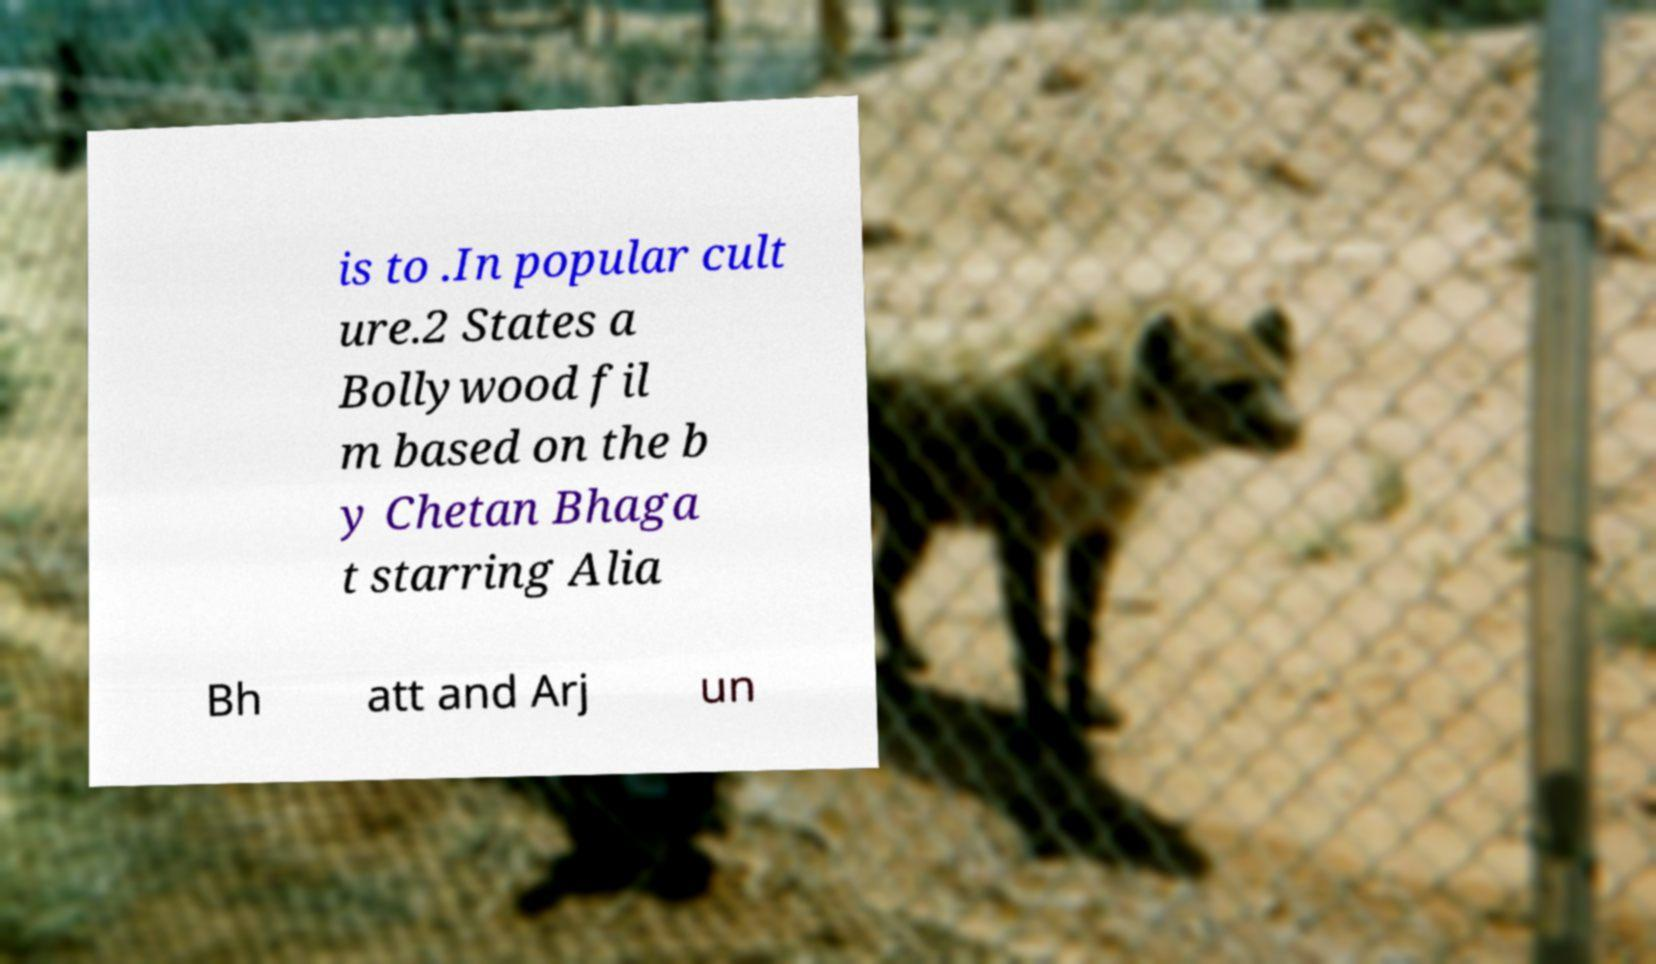For documentation purposes, I need the text within this image transcribed. Could you provide that? is to .In popular cult ure.2 States a Bollywood fil m based on the b y Chetan Bhaga t starring Alia Bh att and Arj un 